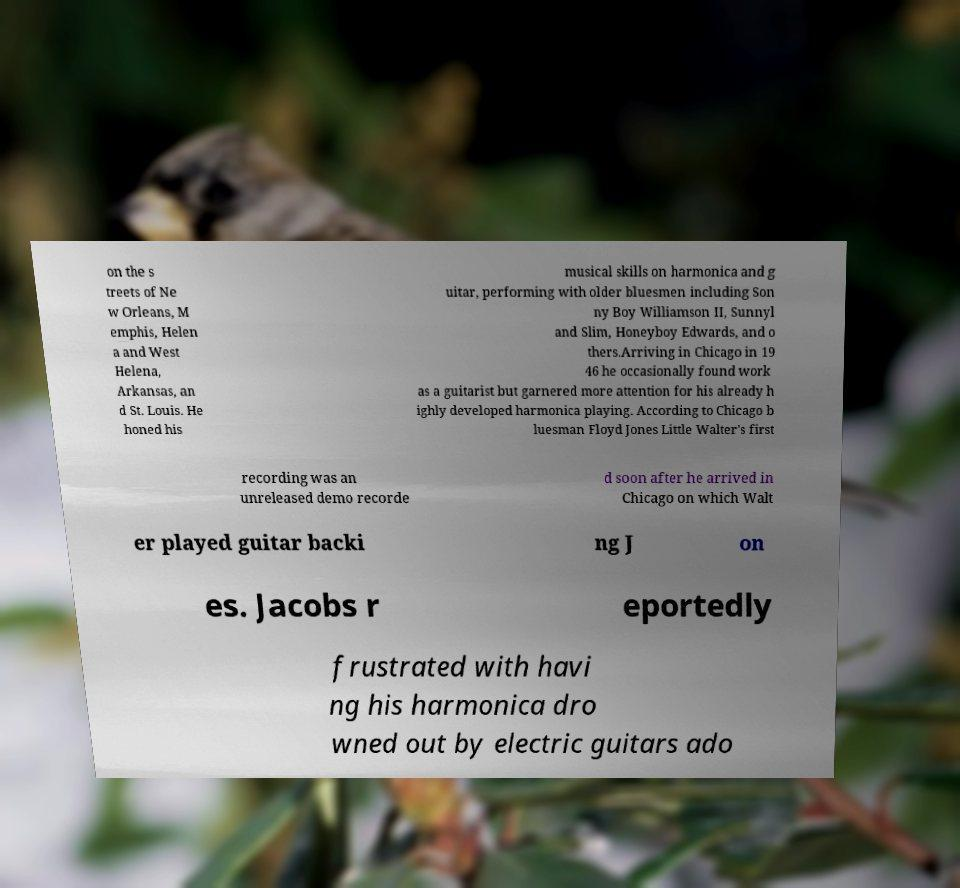Please read and relay the text visible in this image. What does it say? on the s treets of Ne w Orleans, M emphis, Helen a and West Helena, Arkansas, an d St. Louis. He honed his musical skills on harmonica and g uitar, performing with older bluesmen including Son ny Boy Williamson II, Sunnyl and Slim, Honeyboy Edwards, and o thers.Arriving in Chicago in 19 46 he occasionally found work as a guitarist but garnered more attention for his already h ighly developed harmonica playing. According to Chicago b luesman Floyd Jones Little Walter's first recording was an unreleased demo recorde d soon after he arrived in Chicago on which Walt er played guitar backi ng J on es. Jacobs r eportedly frustrated with havi ng his harmonica dro wned out by electric guitars ado 